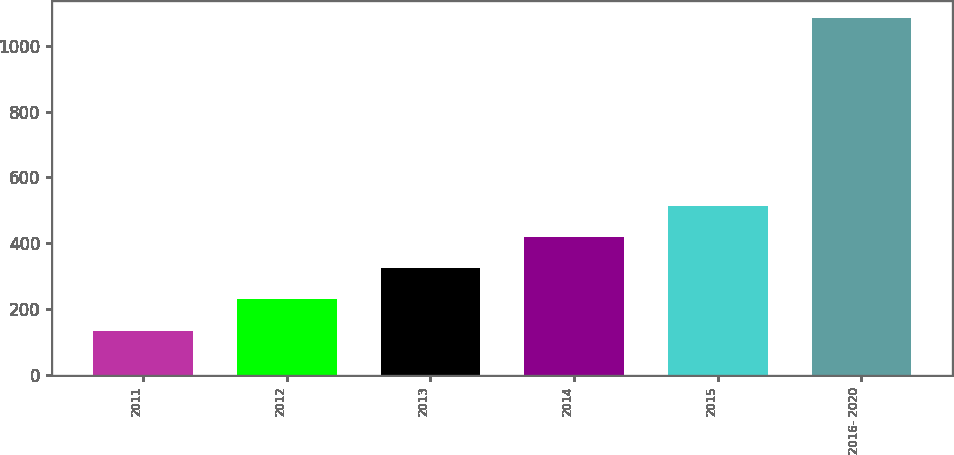<chart> <loc_0><loc_0><loc_500><loc_500><bar_chart><fcel>2011<fcel>2012<fcel>2013<fcel>2014<fcel>2015<fcel>2016- 2020<nl><fcel>134<fcel>228.9<fcel>323.8<fcel>418.7<fcel>513.6<fcel>1083<nl></chart> 